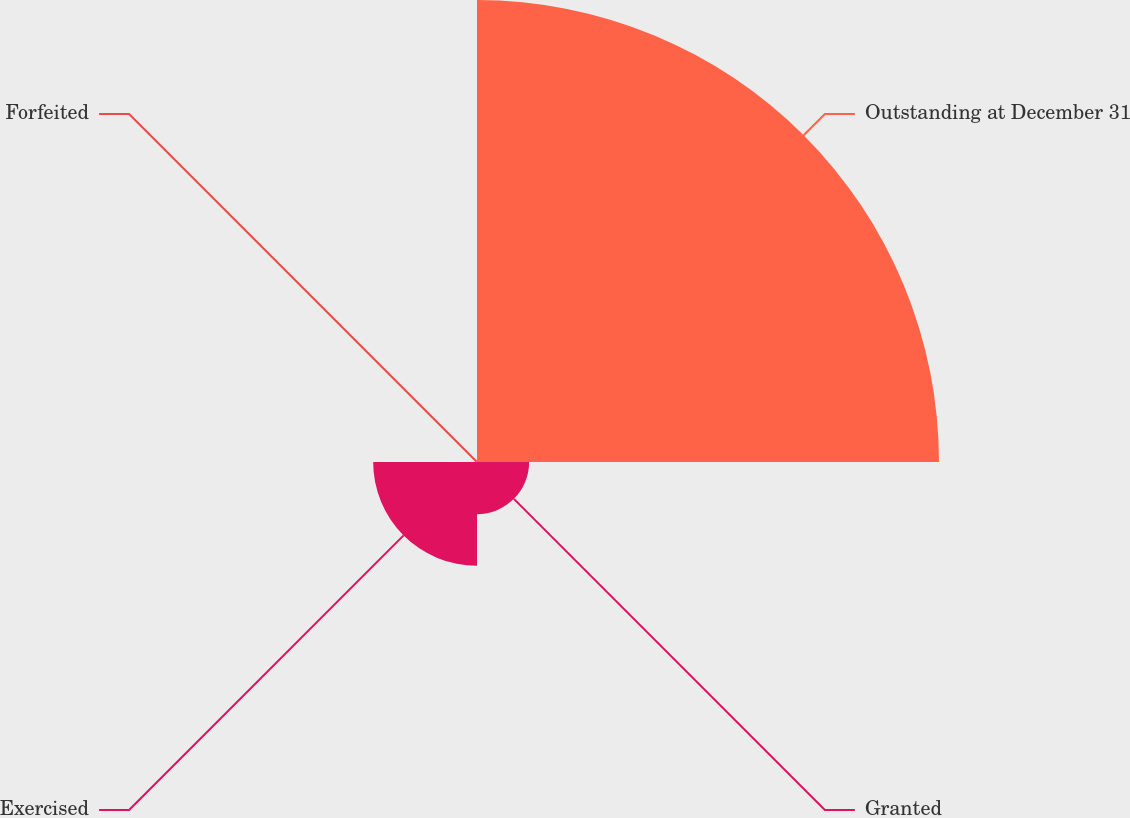Convert chart to OTSL. <chart><loc_0><loc_0><loc_500><loc_500><pie_chart><fcel>Outstanding at December 31<fcel>Granted<fcel>Exercised<fcel>Forfeited<nl><fcel>74.71%<fcel>8.43%<fcel>16.79%<fcel>0.07%<nl></chart> 